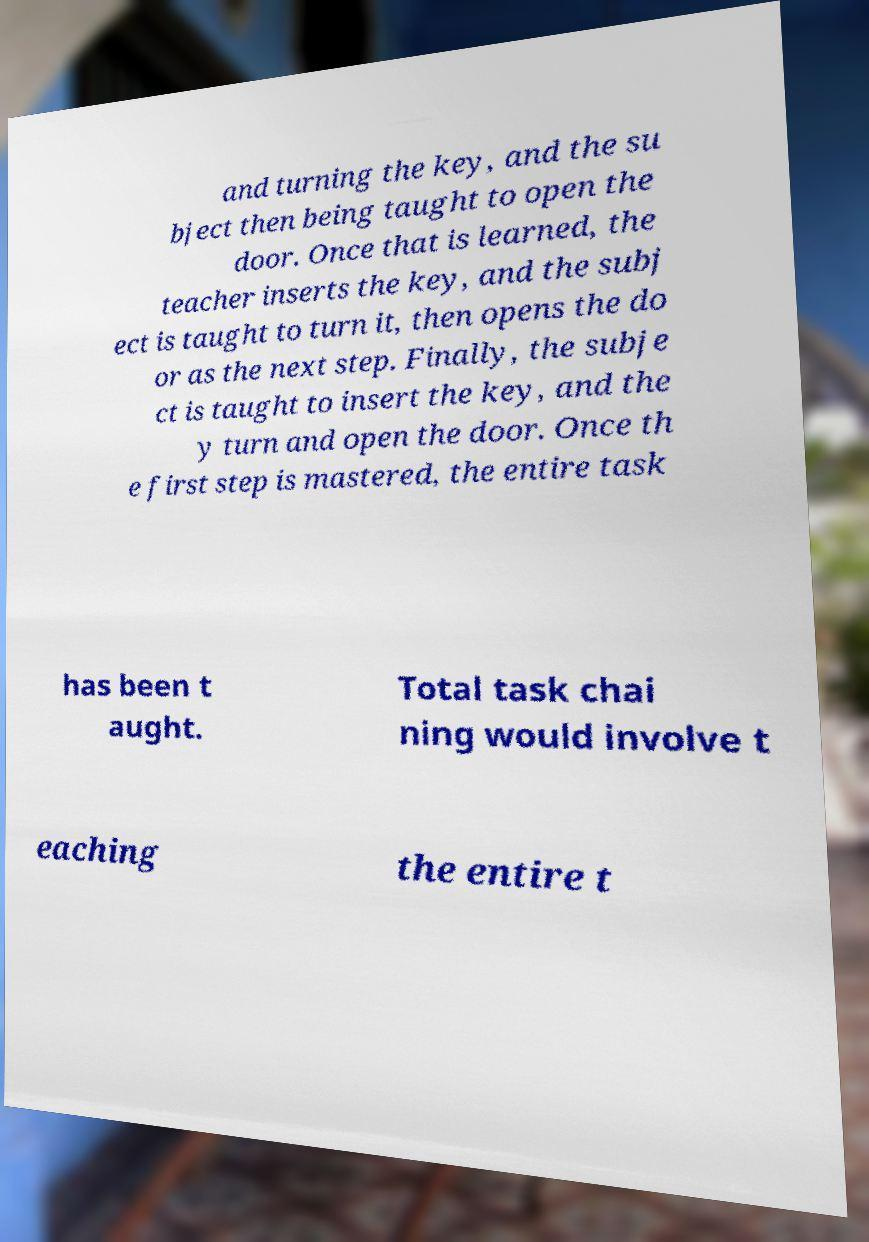For documentation purposes, I need the text within this image transcribed. Could you provide that? and turning the key, and the su bject then being taught to open the door. Once that is learned, the teacher inserts the key, and the subj ect is taught to turn it, then opens the do or as the next step. Finally, the subje ct is taught to insert the key, and the y turn and open the door. Once th e first step is mastered, the entire task has been t aught. Total task chai ning would involve t eaching the entire t 